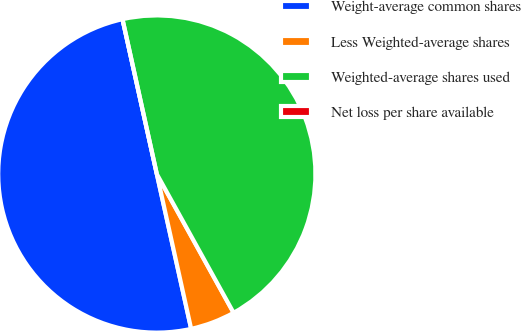Convert chart. <chart><loc_0><loc_0><loc_500><loc_500><pie_chart><fcel>Weight-average common shares<fcel>Less Weighted-average shares<fcel>Weighted-average shares used<fcel>Net loss per share available<nl><fcel>50.0%<fcel>4.57%<fcel>45.43%<fcel>0.0%<nl></chart> 